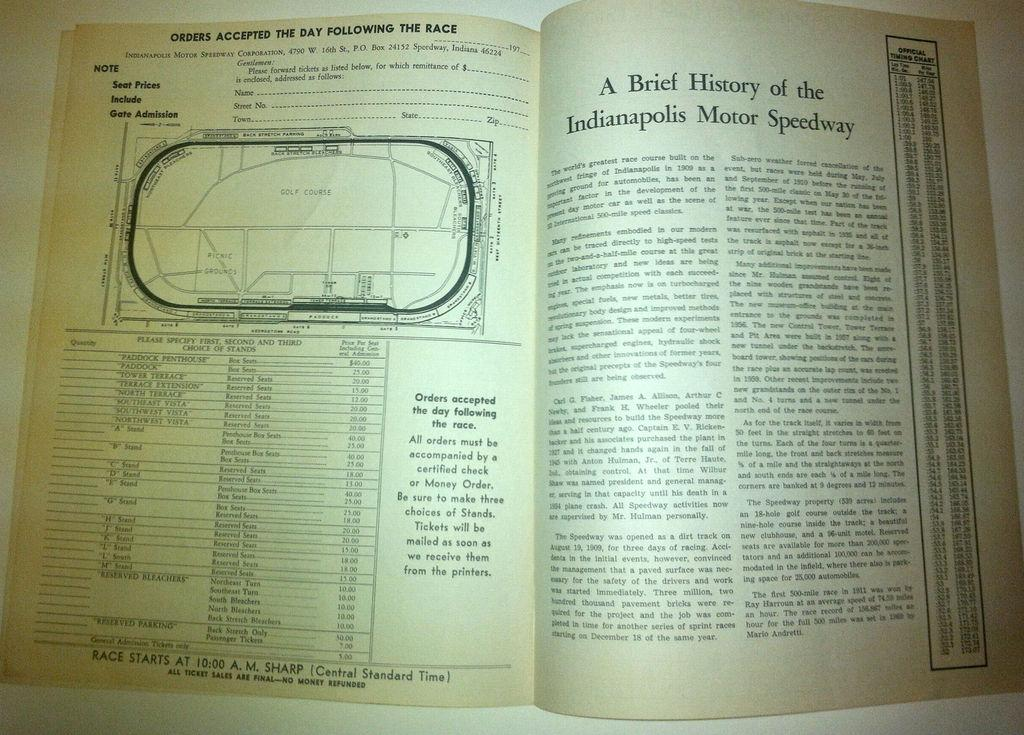<image>
Write a terse but informative summary of the picture. A book is open to a page about the history of the Indianapolis Motor Speedway. 